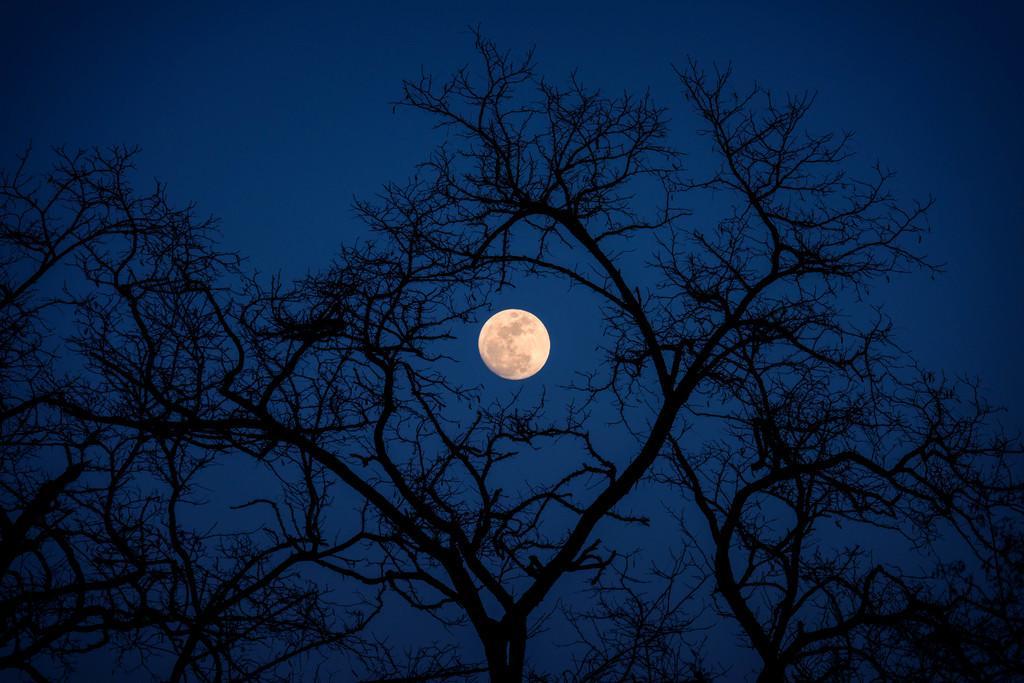Describe this image in one or two sentences. In this image we can see there are trees. In the background there is the moon in the sky. 